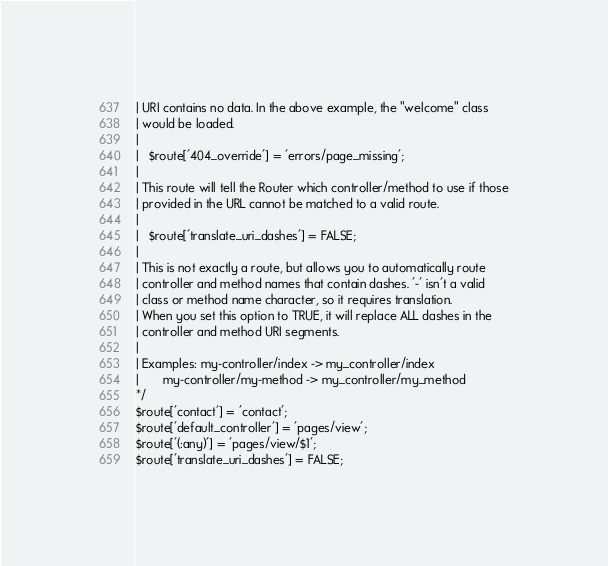Convert code to text. <code><loc_0><loc_0><loc_500><loc_500><_PHP_>| URI contains no data. In the above example, the "welcome" class
| would be loaded.
|
|	$route['404_override'] = 'errors/page_missing';
|
| This route will tell the Router which controller/method to use if those
| provided in the URL cannot be matched to a valid route.
|
|	$route['translate_uri_dashes'] = FALSE;
|
| This is not exactly a route, but allows you to automatically route
| controller and method names that contain dashes. '-' isn't a valid
| class or method name character, so it requires translation.
| When you set this option to TRUE, it will replace ALL dashes in the
| controller and method URI segments.
|
| Examples:	my-controller/index	-> my_controller/index
|		my-controller/my-method	-> my_controller/my_method
*/
$route['contact'] = 'contact';
$route['default_controller'] = 'pages/view';
$route['(:any)'] = 'pages/view/$1';
$route['translate_uri_dashes'] = FALSE;
</code> 